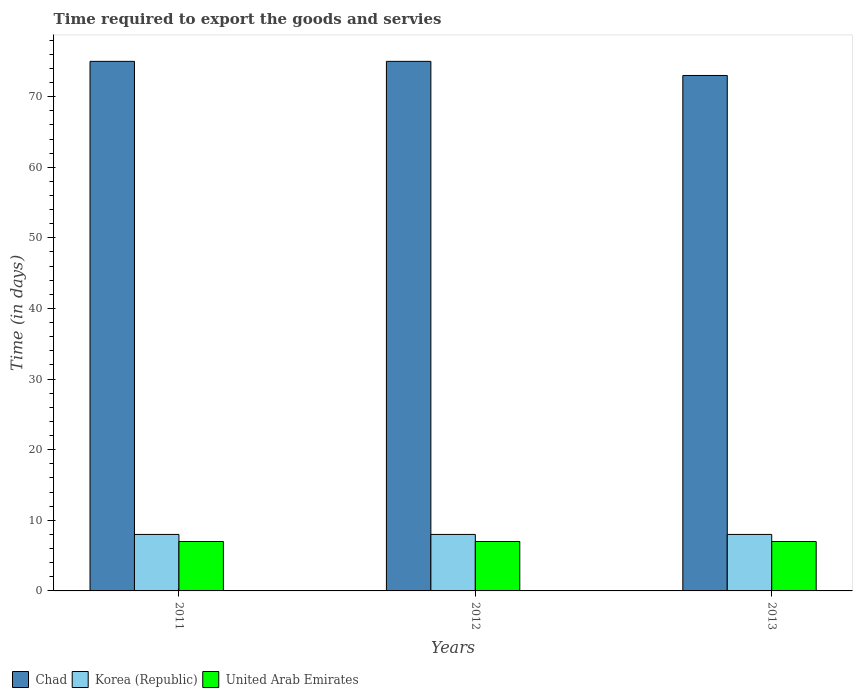How many different coloured bars are there?
Keep it short and to the point. 3. How many groups of bars are there?
Make the answer very short. 3. Are the number of bars on each tick of the X-axis equal?
Offer a terse response. Yes. How many bars are there on the 1st tick from the left?
Your answer should be compact. 3. What is the label of the 3rd group of bars from the left?
Provide a succinct answer. 2013. What is the number of days required to export the goods and services in Chad in 2012?
Your answer should be very brief. 75. Across all years, what is the maximum number of days required to export the goods and services in United Arab Emirates?
Make the answer very short. 7. Across all years, what is the minimum number of days required to export the goods and services in United Arab Emirates?
Make the answer very short. 7. In which year was the number of days required to export the goods and services in United Arab Emirates maximum?
Provide a succinct answer. 2011. In which year was the number of days required to export the goods and services in Korea (Republic) minimum?
Make the answer very short. 2011. What is the total number of days required to export the goods and services in Korea (Republic) in the graph?
Keep it short and to the point. 24. What is the difference between the number of days required to export the goods and services in Chad in 2012 and that in 2013?
Ensure brevity in your answer.  2. What is the difference between the number of days required to export the goods and services in United Arab Emirates in 2011 and the number of days required to export the goods and services in Korea (Republic) in 2013?
Provide a short and direct response. -1. In the year 2011, what is the difference between the number of days required to export the goods and services in Korea (Republic) and number of days required to export the goods and services in Chad?
Your answer should be very brief. -67. In how many years, is the number of days required to export the goods and services in United Arab Emirates greater than 48 days?
Your answer should be compact. 0. Is the number of days required to export the goods and services in United Arab Emirates in 2011 less than that in 2013?
Provide a succinct answer. No. Is the difference between the number of days required to export the goods and services in Korea (Republic) in 2012 and 2013 greater than the difference between the number of days required to export the goods and services in Chad in 2012 and 2013?
Offer a terse response. No. What is the difference between the highest and the second highest number of days required to export the goods and services in Korea (Republic)?
Your answer should be compact. 0. What is the difference between the highest and the lowest number of days required to export the goods and services in Chad?
Offer a very short reply. 2. In how many years, is the number of days required to export the goods and services in Korea (Republic) greater than the average number of days required to export the goods and services in Korea (Republic) taken over all years?
Provide a short and direct response. 0. Is the sum of the number of days required to export the goods and services in United Arab Emirates in 2011 and 2013 greater than the maximum number of days required to export the goods and services in Korea (Republic) across all years?
Your answer should be compact. Yes. Is it the case that in every year, the sum of the number of days required to export the goods and services in United Arab Emirates and number of days required to export the goods and services in Korea (Republic) is greater than the number of days required to export the goods and services in Chad?
Offer a terse response. No. Are all the bars in the graph horizontal?
Provide a short and direct response. No. How many years are there in the graph?
Your answer should be very brief. 3. Where does the legend appear in the graph?
Keep it short and to the point. Bottom left. How many legend labels are there?
Keep it short and to the point. 3. How are the legend labels stacked?
Give a very brief answer. Horizontal. What is the title of the graph?
Provide a short and direct response. Time required to export the goods and servies. Does "Vanuatu" appear as one of the legend labels in the graph?
Your answer should be very brief. No. What is the label or title of the X-axis?
Your answer should be compact. Years. What is the label or title of the Y-axis?
Ensure brevity in your answer.  Time (in days). What is the Time (in days) in Chad in 2011?
Your response must be concise. 75. What is the Time (in days) of Korea (Republic) in 2011?
Provide a succinct answer. 8. What is the Time (in days) of Korea (Republic) in 2012?
Ensure brevity in your answer.  8. What is the Time (in days) of United Arab Emirates in 2012?
Give a very brief answer. 7. What is the Time (in days) in Korea (Republic) in 2013?
Offer a very short reply. 8. Across all years, what is the maximum Time (in days) of Chad?
Give a very brief answer. 75. Across all years, what is the maximum Time (in days) of United Arab Emirates?
Your answer should be very brief. 7. What is the total Time (in days) in Chad in the graph?
Provide a succinct answer. 223. What is the total Time (in days) of Korea (Republic) in the graph?
Make the answer very short. 24. What is the total Time (in days) of United Arab Emirates in the graph?
Keep it short and to the point. 21. What is the difference between the Time (in days) in Chad in 2011 and that in 2012?
Ensure brevity in your answer.  0. What is the difference between the Time (in days) in Chad in 2011 and that in 2013?
Your answer should be very brief. 2. What is the difference between the Time (in days) in United Arab Emirates in 2012 and that in 2013?
Offer a terse response. 0. What is the difference between the Time (in days) of Korea (Republic) in 2011 and the Time (in days) of United Arab Emirates in 2012?
Offer a very short reply. 1. What is the difference between the Time (in days) of Chad in 2011 and the Time (in days) of Korea (Republic) in 2013?
Ensure brevity in your answer.  67. What is the difference between the Time (in days) in Chad in 2012 and the Time (in days) in United Arab Emirates in 2013?
Keep it short and to the point. 68. What is the difference between the Time (in days) of Korea (Republic) in 2012 and the Time (in days) of United Arab Emirates in 2013?
Provide a succinct answer. 1. What is the average Time (in days) of Chad per year?
Your response must be concise. 74.33. In the year 2011, what is the difference between the Time (in days) of Chad and Time (in days) of United Arab Emirates?
Keep it short and to the point. 68. In the year 2011, what is the difference between the Time (in days) of Korea (Republic) and Time (in days) of United Arab Emirates?
Provide a short and direct response. 1. In the year 2012, what is the difference between the Time (in days) of Chad and Time (in days) of Korea (Republic)?
Offer a very short reply. 67. In the year 2012, what is the difference between the Time (in days) in Chad and Time (in days) in United Arab Emirates?
Provide a short and direct response. 68. In the year 2013, what is the difference between the Time (in days) in Chad and Time (in days) in Korea (Republic)?
Give a very brief answer. 65. In the year 2013, what is the difference between the Time (in days) in Chad and Time (in days) in United Arab Emirates?
Keep it short and to the point. 66. What is the ratio of the Time (in days) of Chad in 2011 to that in 2013?
Ensure brevity in your answer.  1.03. What is the ratio of the Time (in days) in Korea (Republic) in 2011 to that in 2013?
Your answer should be compact. 1. What is the ratio of the Time (in days) in Chad in 2012 to that in 2013?
Offer a terse response. 1.03. What is the ratio of the Time (in days) of Korea (Republic) in 2012 to that in 2013?
Your answer should be compact. 1. What is the ratio of the Time (in days) in United Arab Emirates in 2012 to that in 2013?
Keep it short and to the point. 1. What is the difference between the highest and the second highest Time (in days) in Chad?
Provide a short and direct response. 0. What is the difference between the highest and the second highest Time (in days) in Korea (Republic)?
Offer a very short reply. 0. What is the difference between the highest and the second highest Time (in days) in United Arab Emirates?
Ensure brevity in your answer.  0. What is the difference between the highest and the lowest Time (in days) in Chad?
Provide a succinct answer. 2. What is the difference between the highest and the lowest Time (in days) in Korea (Republic)?
Give a very brief answer. 0. What is the difference between the highest and the lowest Time (in days) of United Arab Emirates?
Offer a very short reply. 0. 